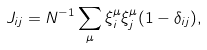Convert formula to latex. <formula><loc_0><loc_0><loc_500><loc_500>J _ { i j } = N ^ { - 1 } \sum _ { \mu } \xi ^ { \mu } _ { i } \xi ^ { \mu } _ { j } ( 1 - \delta _ { i j } ) ,</formula> 